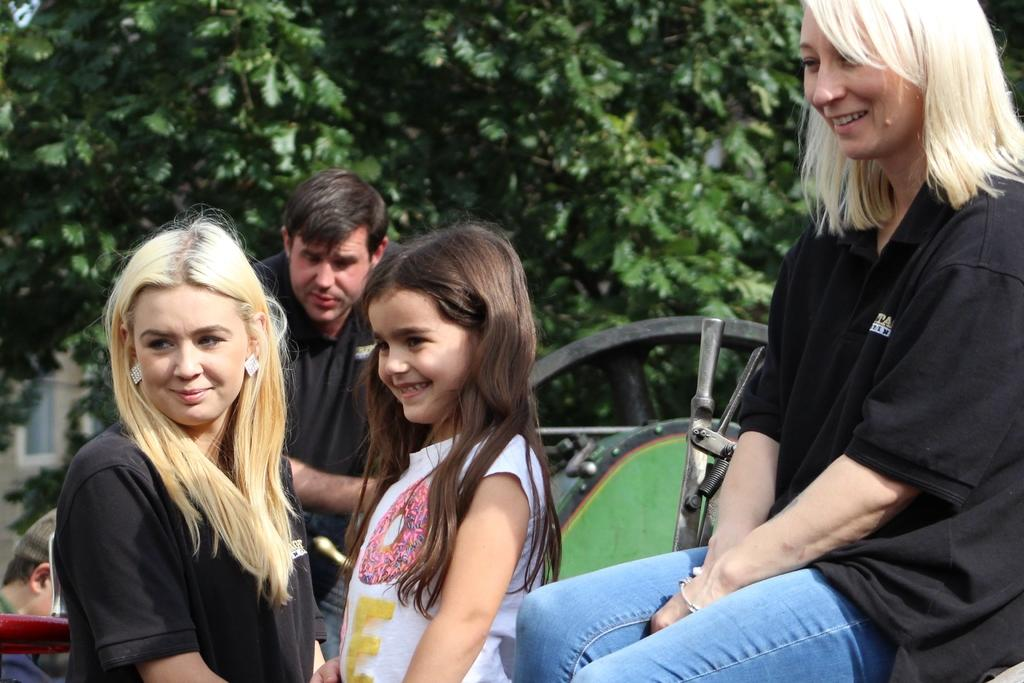How many people are in the foreground of the image? There are two women and a girl in the image. What is the facial expression of the people in the foreground? The women and the girl are smiling. Can you describe the background of the image? There are two people and some objects in the background of the image, as well as trees. What type of calculator can be seen in the image? There is no calculator present in the image. Can you compare the teeth of the two women in the image? There is no information about the teeth of the women in the image, as it only shows their smiles. 